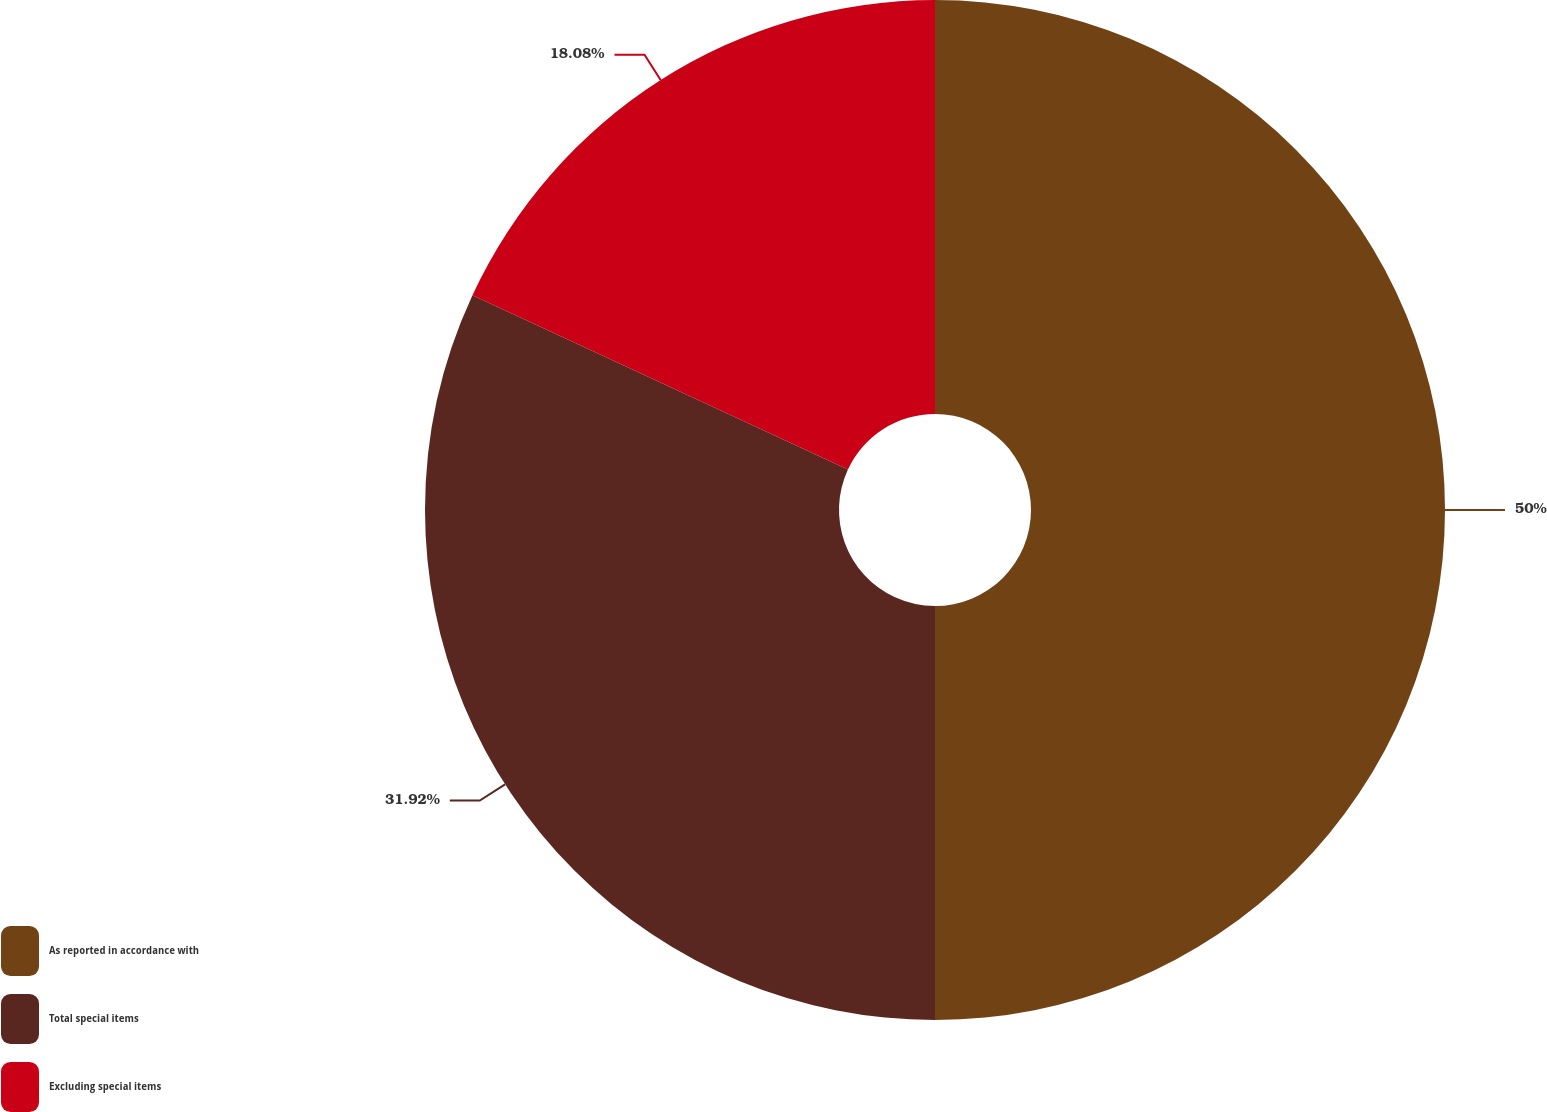Convert chart. <chart><loc_0><loc_0><loc_500><loc_500><pie_chart><fcel>As reported in accordance with<fcel>Total special items<fcel>Excluding special items<nl><fcel>50.0%<fcel>31.92%<fcel>18.08%<nl></chart> 